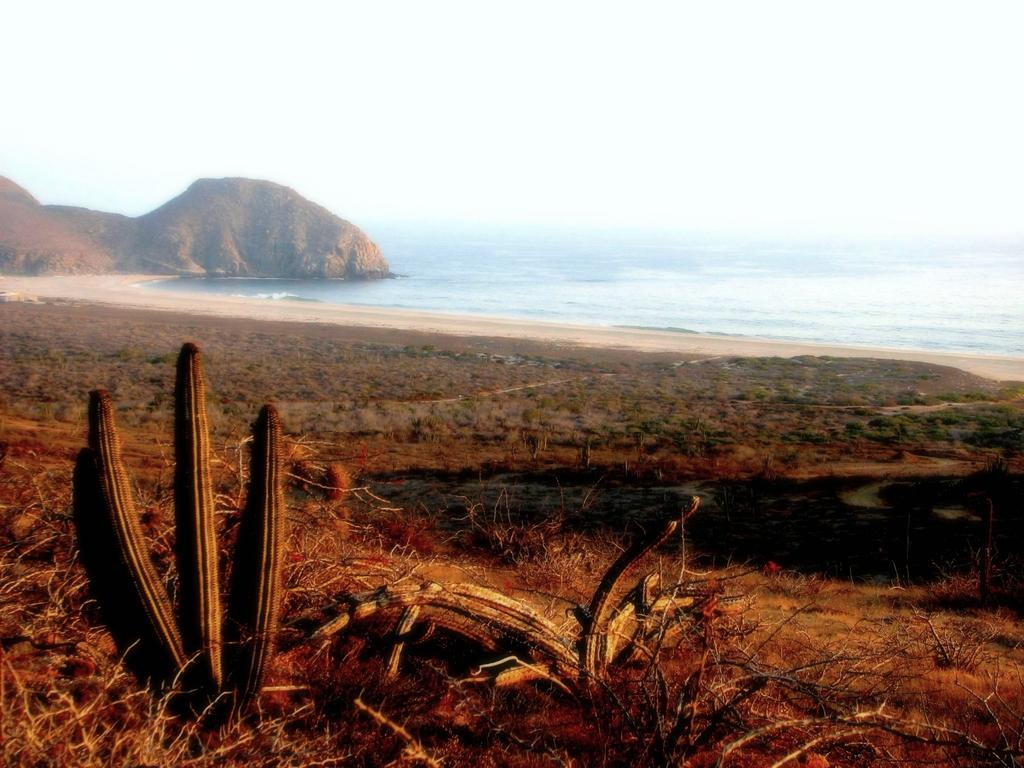What type of living organisms can be seen in the image? Plants can be seen in the image. What natural element is visible in the image? Water and sand are visible in the image. What geological feature is present in the image? There is a rock in the image. What can be seen in the sky in the image? Clouds are visible in the sky in the image. Where is the father in the image? There is no father present in the image. What type of needle can be seen in the image? There is no needle present in the image. 